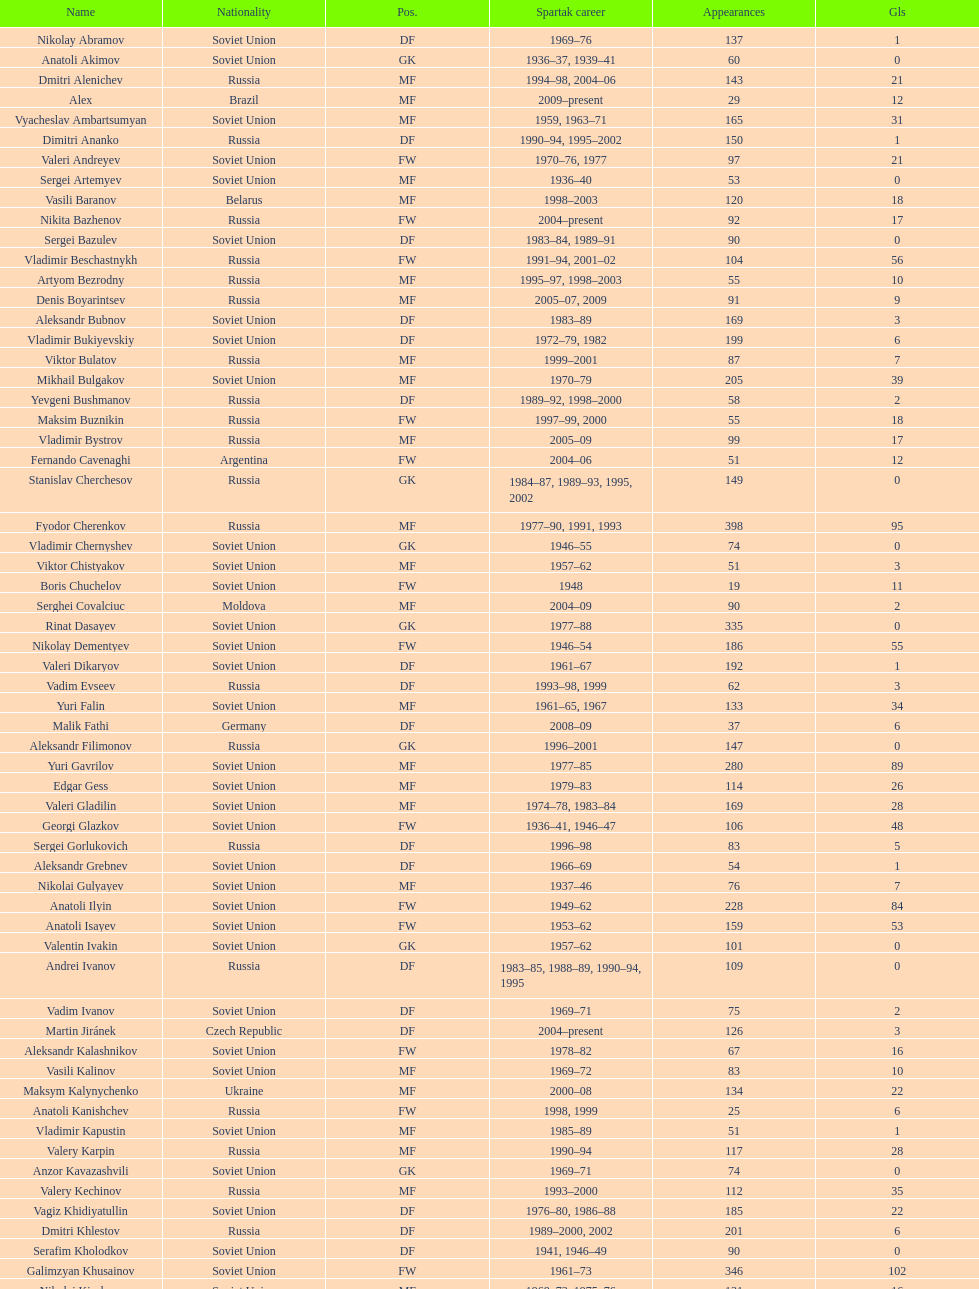Vladimir bukiyevskiy had how many appearances? 199. 